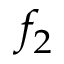<formula> <loc_0><loc_0><loc_500><loc_500>f _ { 2 }</formula> 